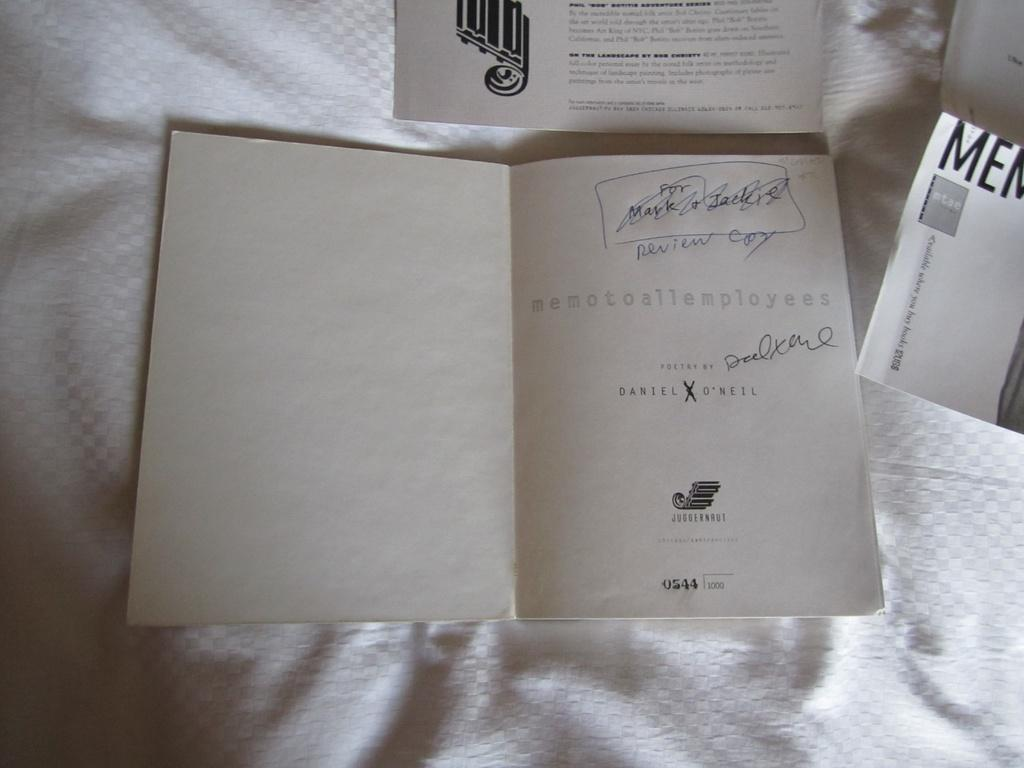<image>
Write a terse but informative summary of the picture. review copy of memo to all employees along with other printed material on a white cloth surface 